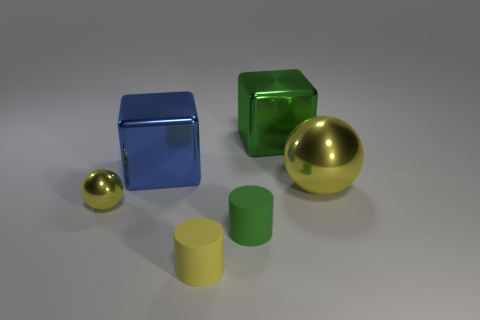Add 2 large green shiny things. How many objects exist? 8 Subtract all spheres. How many objects are left? 4 Subtract 0 blue cylinders. How many objects are left? 6 Subtract all blue metallic cubes. Subtract all big blue metallic blocks. How many objects are left? 4 Add 4 big green metallic cubes. How many big green metallic cubes are left? 5 Add 4 large cylinders. How many large cylinders exist? 4 